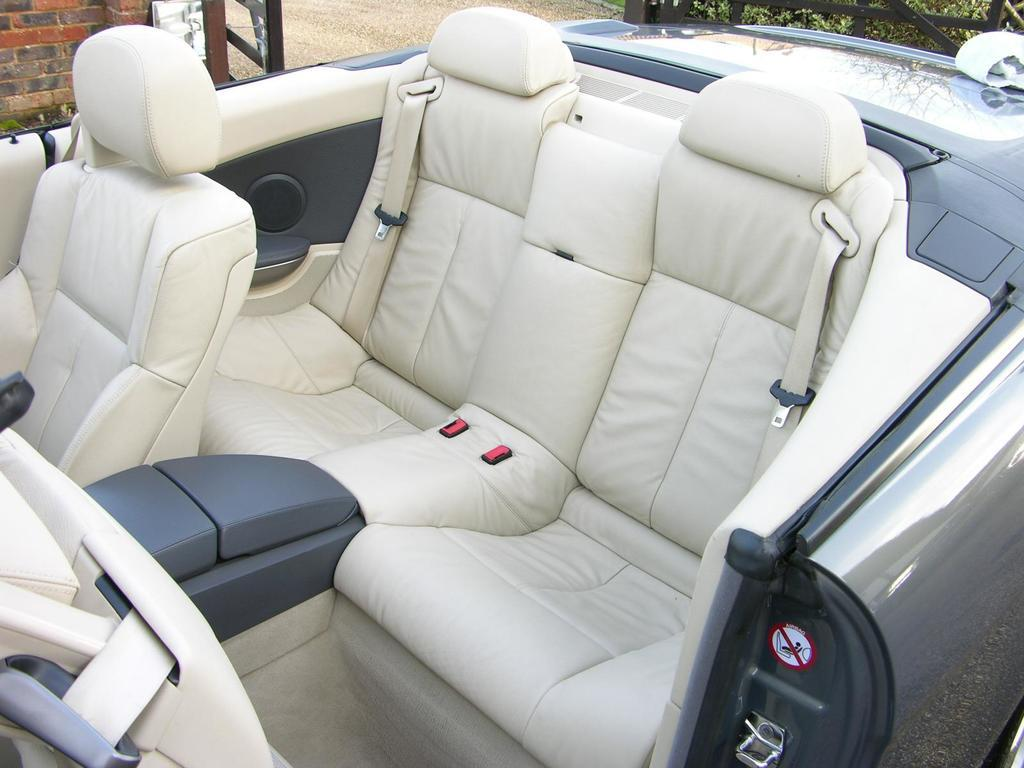What is the main subject in the foreground of the image? There is a car in the foreground of the image. What can be seen in the background of the image? There are plants, a path, and a wall in the background of the image. What type of zinc is visible on the car in the image? There is no zinc visible on the car in the image. Is there a collar visible on any of the plants in the background? There are no collars present on the plants in the image. 